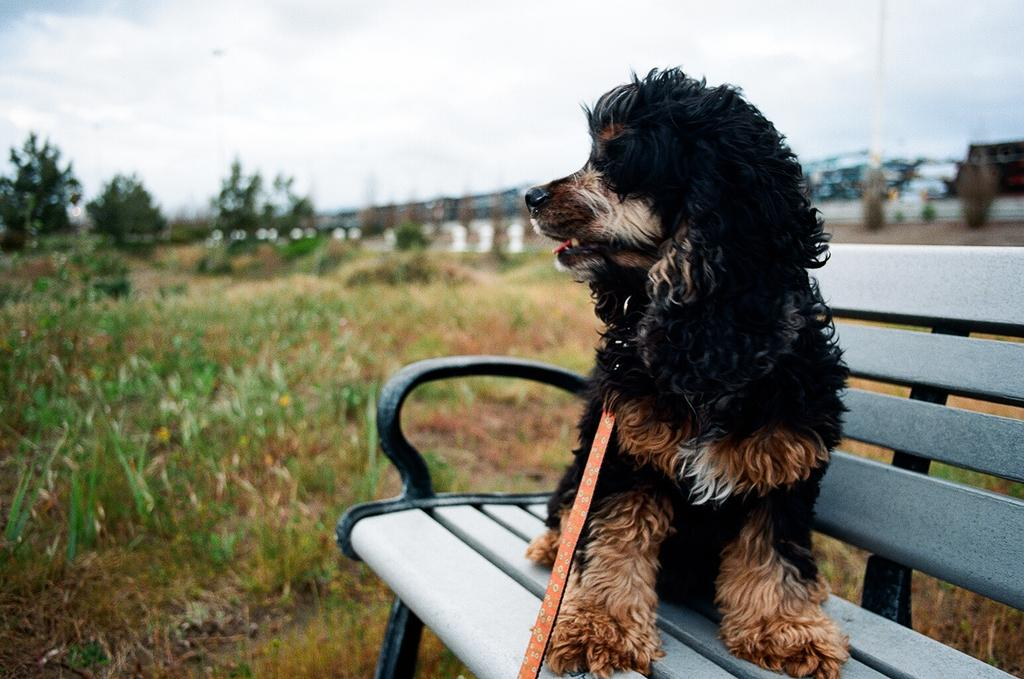What animal is present in the image? There is a dog in the image. Where is the dog located? The dog is on a bench. What can be seen in the background of the image? There are trees, plants, and the sky visible in the background of the image. What is the condition of the sky in the image? The sky is visible with clouds in the background of the image. What type of tool is the dog using to build a wooden structure in the image? There is no carpenter or wooden structure present in the image, and therefore no tools are being used by the dog. What word is written on the dog's collar in the image? There is no text or word visible on the dog's collar in the image. 